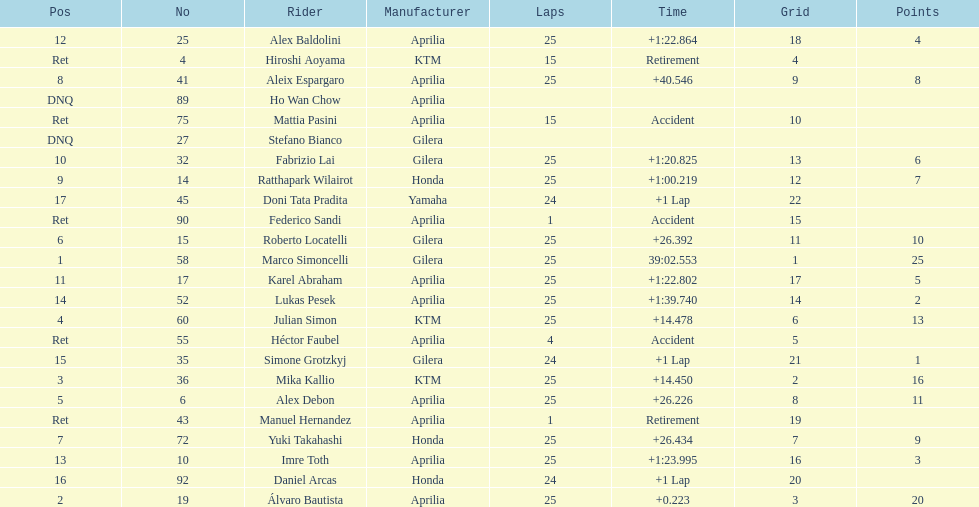How many riders manufacturer is honda? 3. 